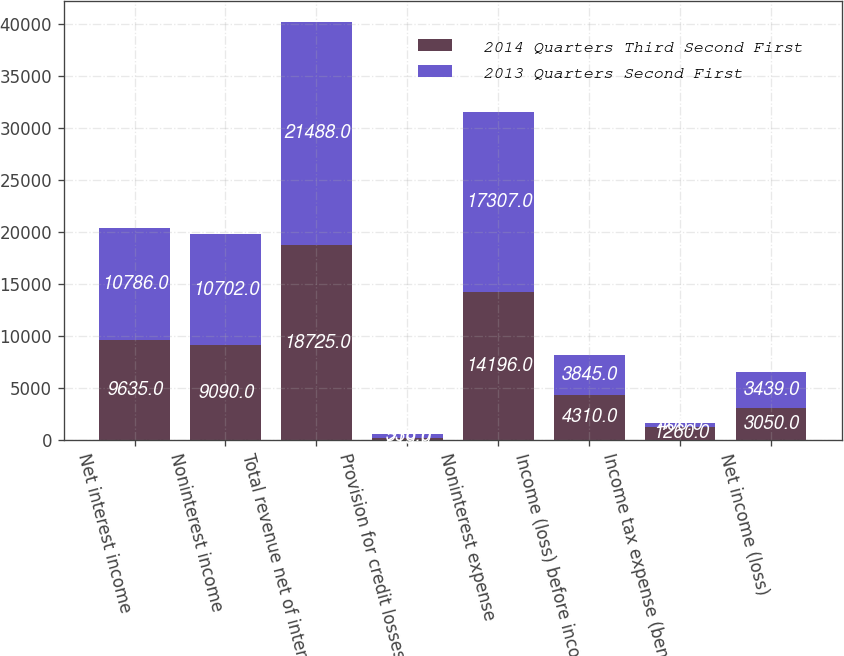<chart> <loc_0><loc_0><loc_500><loc_500><stacked_bar_chart><ecel><fcel>Net interest income<fcel>Noninterest income<fcel>Total revenue net of interest<fcel>Provision for credit losses<fcel>Noninterest expense<fcel>Income (loss) before income<fcel>Income tax expense (benefit)<fcel>Net income (loss)<nl><fcel>2014 Quarters Third Second First<fcel>9635<fcel>9090<fcel>18725<fcel>219<fcel>14196<fcel>4310<fcel>1260<fcel>3050<nl><fcel>2013 Quarters Second First<fcel>10786<fcel>10702<fcel>21488<fcel>336<fcel>17307<fcel>3845<fcel>406<fcel>3439<nl></chart> 